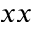<formula> <loc_0><loc_0><loc_500><loc_500>x x</formula> 